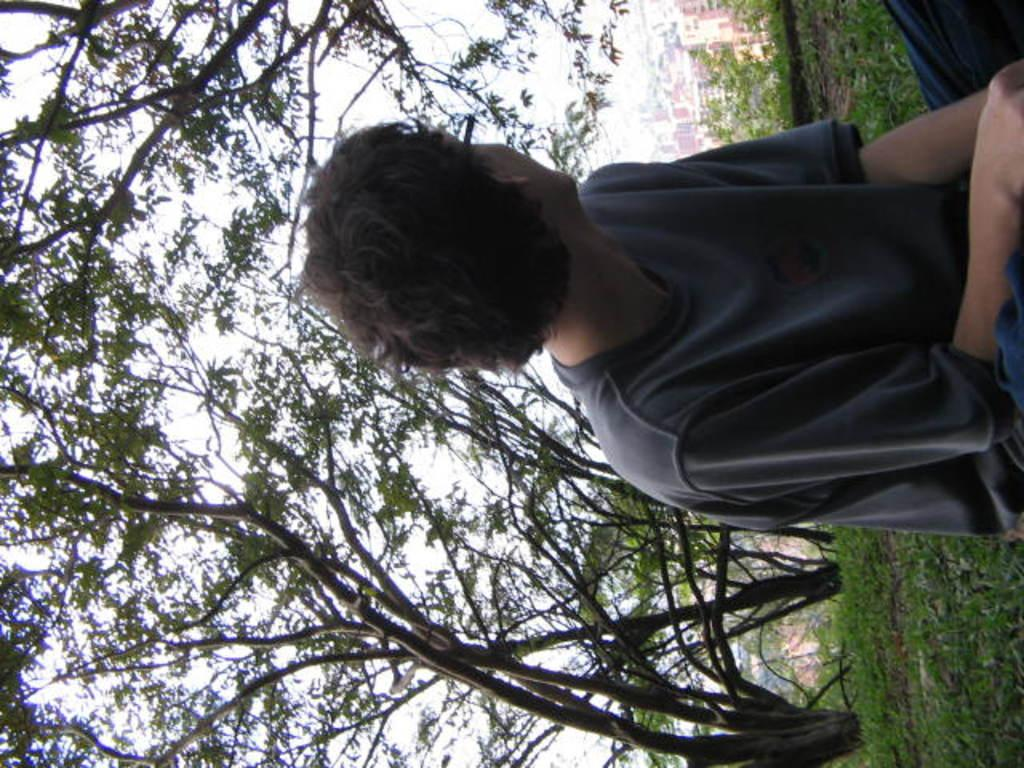What is the person in the image doing? The person is sitting on the ground. What type of surface is the person sitting on? There is grass on the ground. What can be seen in the background of the image? There are buildings and trees in the background of the image. How would you describe the sky in the image? The sky is cloudy. What type of whistle can be heard coming from the trees in the image? There is no whistle present in the image, and no indication of any sound coming from the trees. 